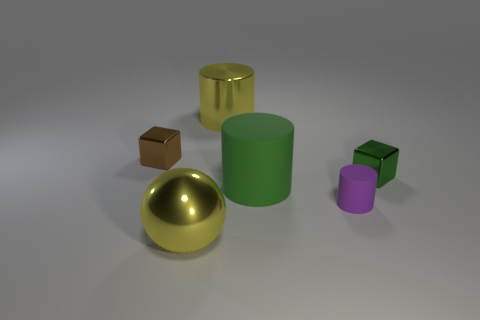What number of tiny things are either purple objects or metal cubes?
Give a very brief answer. 3. What number of metal things are both to the left of the big yellow metallic cylinder and behind the green shiny thing?
Ensure brevity in your answer.  1. Are there more tiny green objects than yellow metal objects?
Provide a short and direct response. No. How many other things are there of the same shape as the purple rubber object?
Keep it short and to the point. 2. Do the metal cylinder and the ball have the same color?
Make the answer very short. Yes. What is the material of the thing that is both to the left of the large yellow cylinder and behind the yellow ball?
Your answer should be very brief. Metal. What size is the metallic cylinder?
Make the answer very short. Large. How many large cylinders are in front of the small metallic cube on the right side of the big yellow metal thing that is on the left side of the large yellow metal cylinder?
Give a very brief answer. 1. There is a shiny thing that is to the right of the yellow object that is behind the tiny green metal object; what is its shape?
Offer a very short reply. Cube. The yellow object that is the same shape as the small purple thing is what size?
Offer a terse response. Large. 